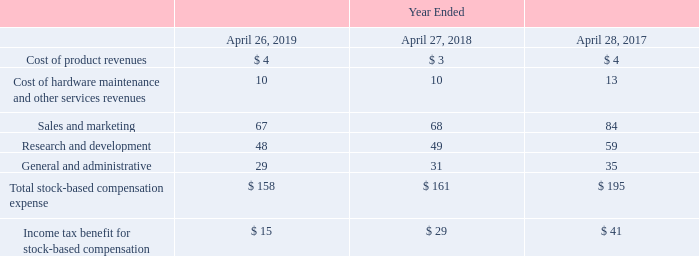Stock-Based Compensation Expense
Stock-based compensation expense is included in the consolidated statements of operations as follows (in millions):
As of April 26, 2019, total unrecognized compensation expense related to our equity awards was $285 million, which is expected to be recognized on a straight-line basis over a weighted-average remaining service period of 2.1 years.
Which years does the table provide information for the company's stock-based compensation expense? 2019, 2018, 2017. What was the cost of product revenues in 2019?
Answer scale should be: million. 4. How many years did the sales and marketing expense exceed $60 million? 2019##2018##2017
Answer: 3. What would be the change in Research and development expense between 2017 and 2018?
Answer scale should be: million. 49-59
Answer: -10. What would be the percentage change in General and administrative expense between 2018 and 2019?
Answer scale should be: percent. (29-31)/31
Answer: -6.45. What would be the total unrecognized compensation expense related to the company's equity awards? $285 million. 